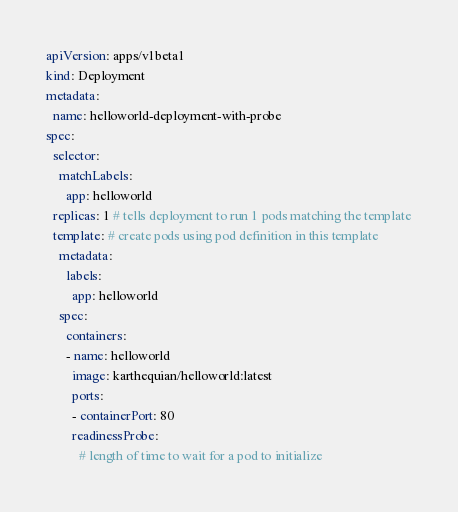Convert code to text. <code><loc_0><loc_0><loc_500><loc_500><_YAML_>apiVersion: apps/v1beta1
kind: Deployment
metadata:
  name: helloworld-deployment-with-probe
spec:
  selector:
    matchLabels:
      app: helloworld
  replicas: 1 # tells deployment to run 1 pods matching the template
  template: # create pods using pod definition in this template
    metadata:
      labels:
        app: helloworld
    spec:
      containers:
      - name: helloworld
        image: karthequian/helloworld:latest
        ports:
        - containerPort: 80
        readinessProbe:
          # length of time to wait for a pod to initialize</code> 